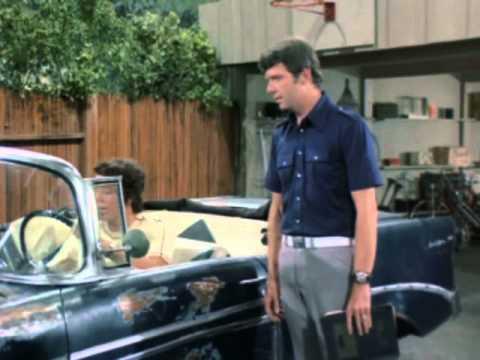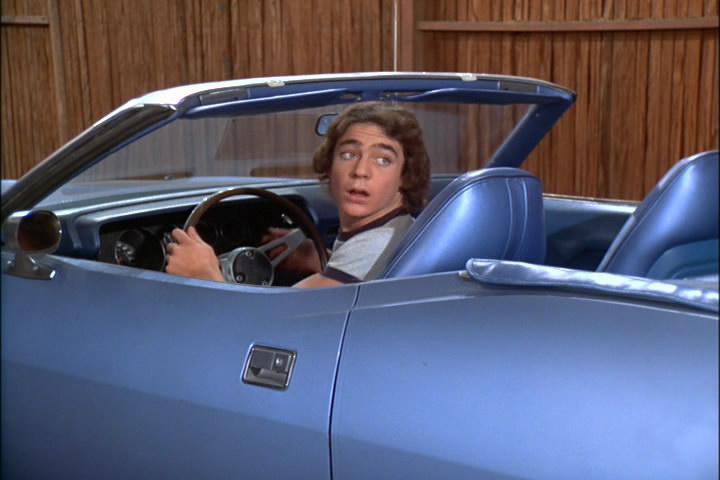The first image is the image on the left, the second image is the image on the right. Analyze the images presented: Is the assertion "An image shows a young man behind the wheel of a powder blue convertible with top down." valid? Answer yes or no. Yes. The first image is the image on the left, the second image is the image on the right. Considering the images on both sides, is "Neither of the cars has a hood or roof on it." valid? Answer yes or no. Yes. 